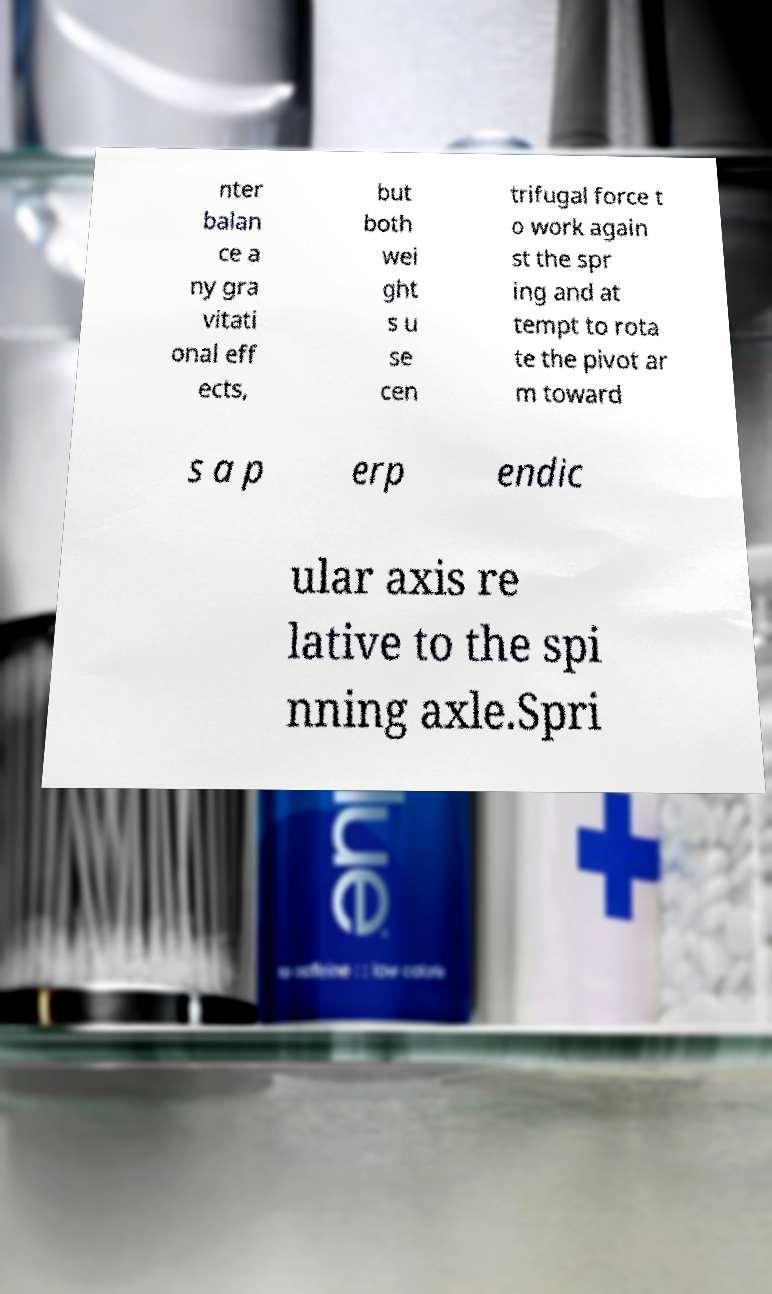Can you read and provide the text displayed in the image?This photo seems to have some interesting text. Can you extract and type it out for me? nter balan ce a ny gra vitati onal eff ects, but both wei ght s u se cen trifugal force t o work again st the spr ing and at tempt to rota te the pivot ar m toward s a p erp endic ular axis re lative to the spi nning axle.Spri 